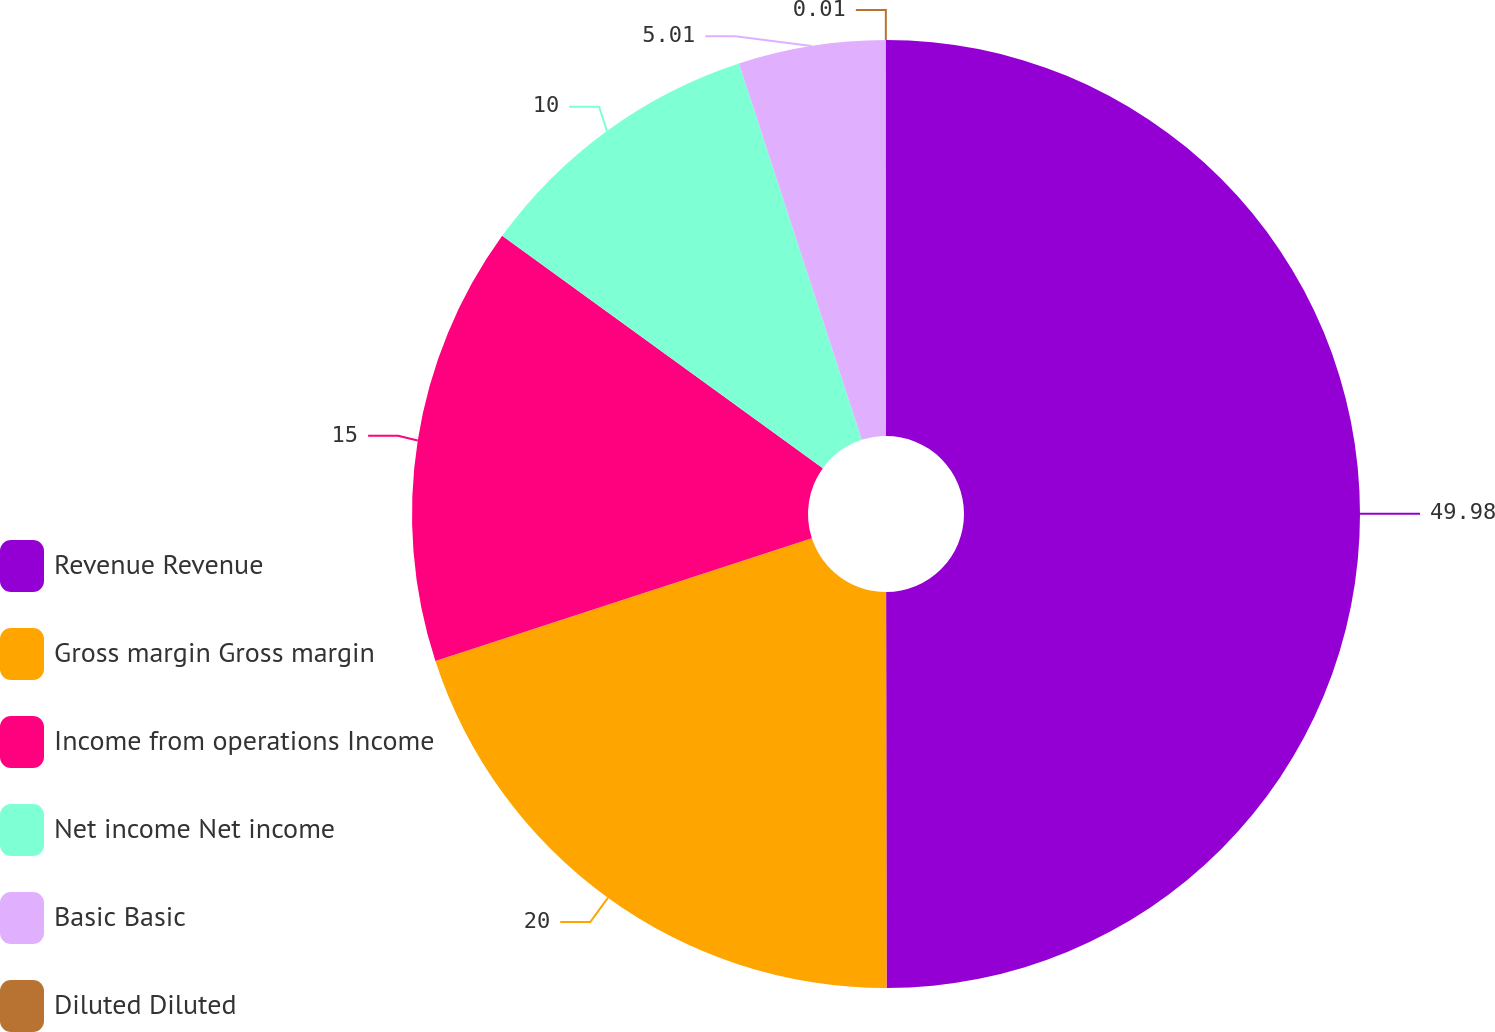<chart> <loc_0><loc_0><loc_500><loc_500><pie_chart><fcel>Revenue Revenue<fcel>Gross margin Gross margin<fcel>Income from operations Income<fcel>Net income Net income<fcel>Basic Basic<fcel>Diluted Diluted<nl><fcel>49.98%<fcel>20.0%<fcel>15.0%<fcel>10.0%<fcel>5.01%<fcel>0.01%<nl></chart> 